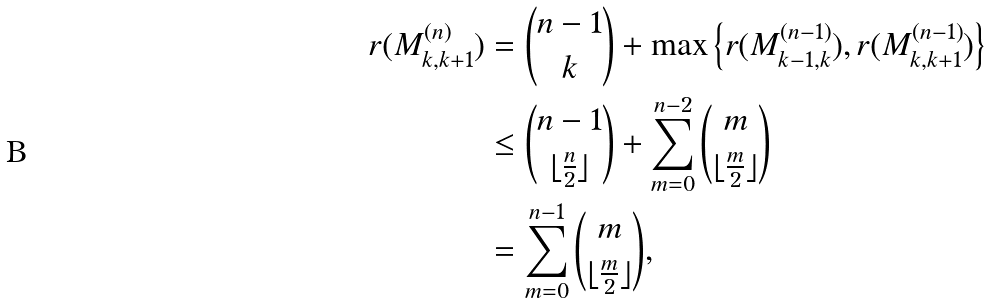<formula> <loc_0><loc_0><loc_500><loc_500>r ( M ^ { ( n ) } _ { k , k + 1 } ) & = \binom { n - 1 } { k } + \max \left \{ r ( M ^ { ( n - 1 ) } _ { k - 1 , k } ) , r ( M ^ { ( n - 1 ) } _ { k , k + 1 } ) \right \} \\ & \leq \binom { n - 1 } { \lfloor \frac { n } { 2 } \rfloor } + \sum _ { m = 0 } ^ { n - 2 } \binom { m } { \lfloor \frac { m } { 2 } \rfloor } \\ & = \sum _ { m = 0 } ^ { n - 1 } \binom { m } { \lfloor \frac { m } { 2 } \rfloor } ,</formula> 